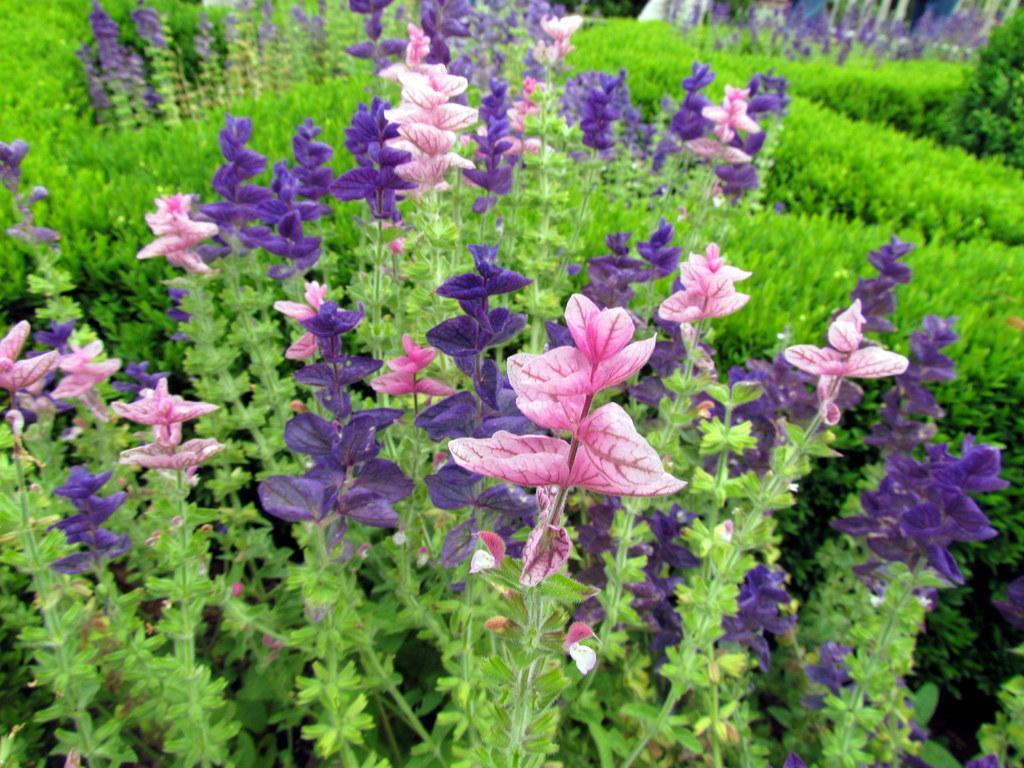In one or two sentences, can you explain what this image depicts? In this image there are flowers and plants. 